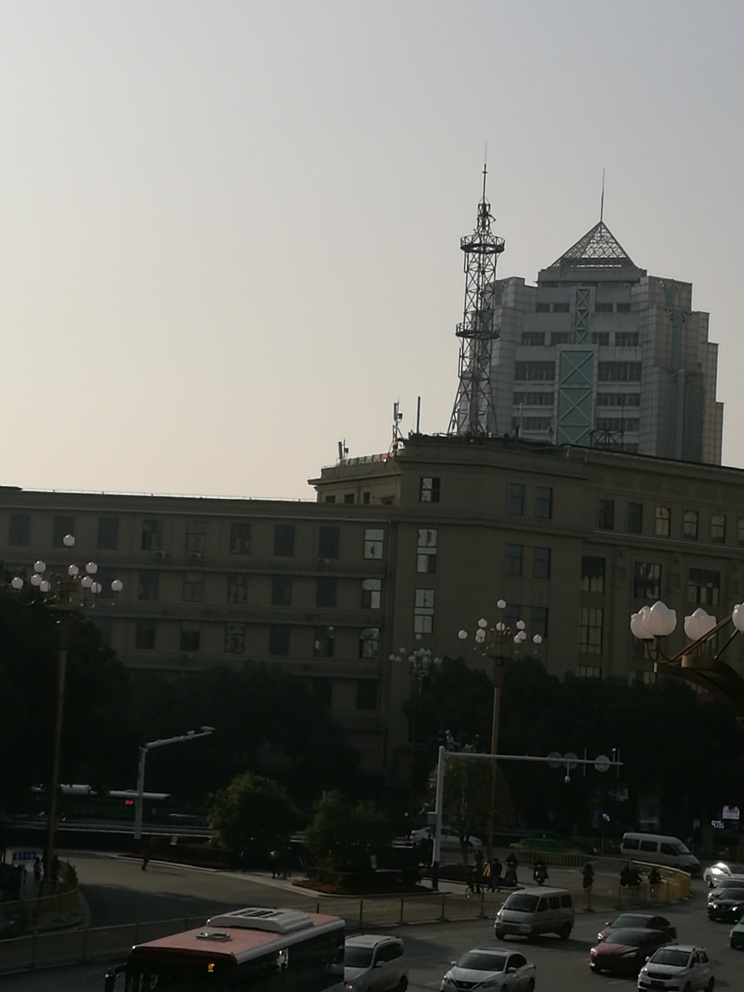Can you describe the style of architecture visible in the image? The image features a blend of architectural styles. In the foreground, there is a classic building with a more traditional design, characterized by its uniform windows and flat roof. Towards the background, there's a more modern high-rise building with distinctive geometrical patterns and a peaked, glass-paneled roof, which reflects a contemporary architectural approach. The contrast between these styles highlights the city's architectural diversity and historical evolution. 